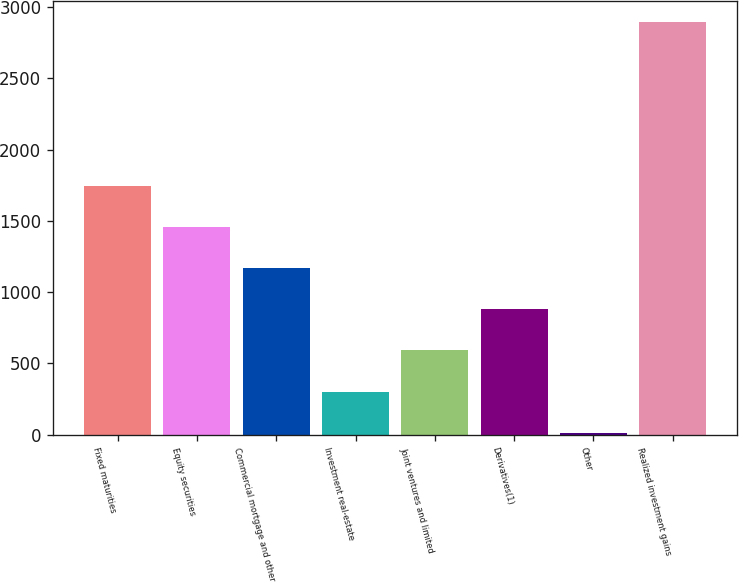<chart> <loc_0><loc_0><loc_500><loc_500><bar_chart><fcel>Fixed maturities<fcel>Equity securities<fcel>Commercial mortgage and other<fcel>Investment real-estate<fcel>Joint ventures and limited<fcel>Derivatives(1)<fcel>Other<fcel>Realized investment gains<nl><fcel>1743.8<fcel>1455.5<fcel>1167.2<fcel>302.3<fcel>590.6<fcel>878.9<fcel>14<fcel>2897<nl></chart> 